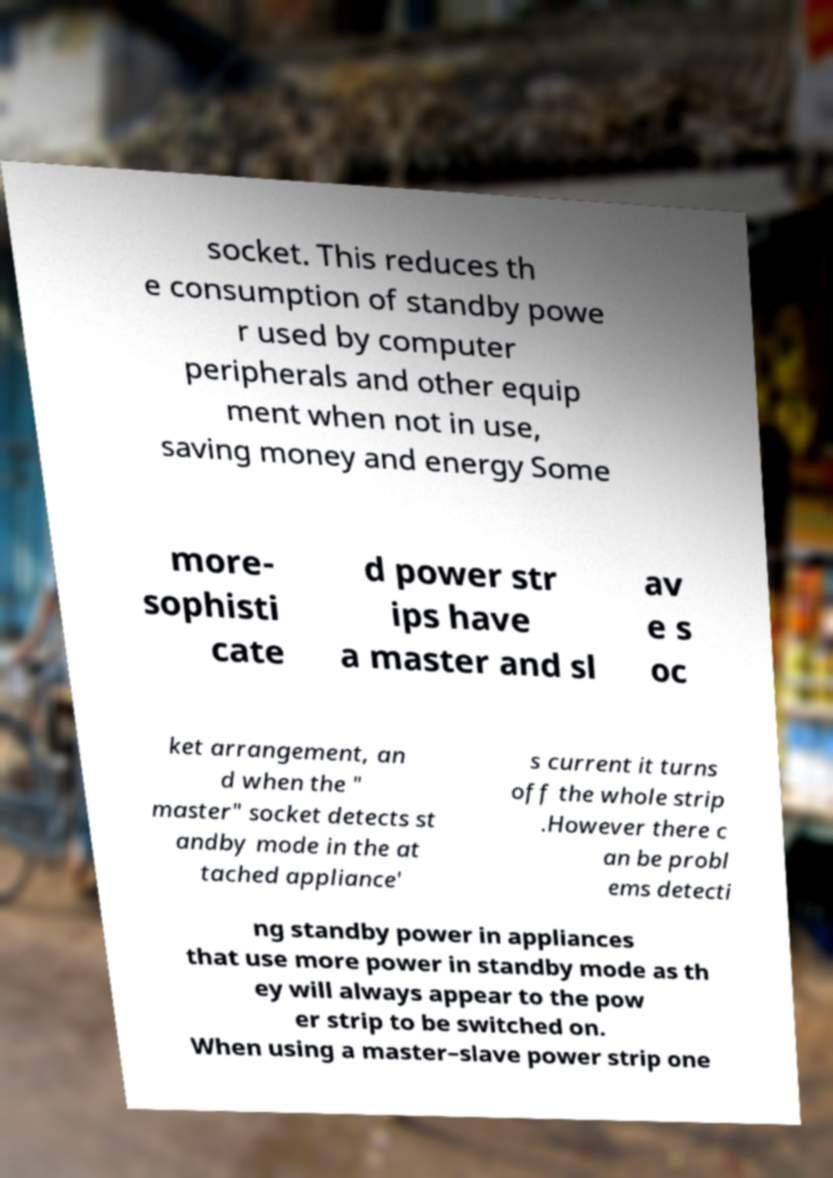Could you assist in decoding the text presented in this image and type it out clearly? socket. This reduces th e consumption of standby powe r used by computer peripherals and other equip ment when not in use, saving money and energy Some more- sophisti cate d power str ips have a master and sl av e s oc ket arrangement, an d when the " master" socket detects st andby mode in the at tached appliance' s current it turns off the whole strip .However there c an be probl ems detecti ng standby power in appliances that use more power in standby mode as th ey will always appear to the pow er strip to be switched on. When using a master–slave power strip one 